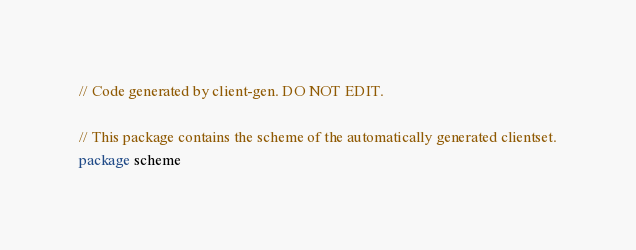<code> <loc_0><loc_0><loc_500><loc_500><_Go_>
// Code generated by client-gen. DO NOT EDIT.

// This package contains the scheme of the automatically generated clientset.
package scheme
</code> 